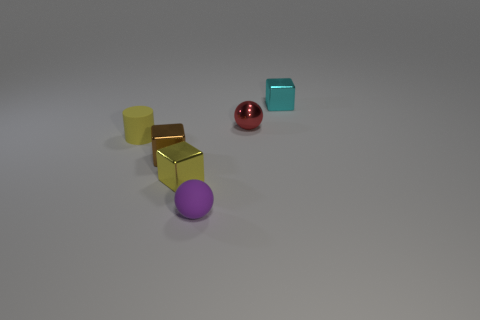Add 1 small red things. How many objects exist? 7 Subtract all cylinders. How many objects are left? 5 Add 4 large purple shiny balls. How many large purple shiny balls exist? 4 Subtract 1 yellow cubes. How many objects are left? 5 Subtract all big purple blocks. Subtract all small yellow metallic things. How many objects are left? 5 Add 1 tiny metal balls. How many tiny metal balls are left? 2 